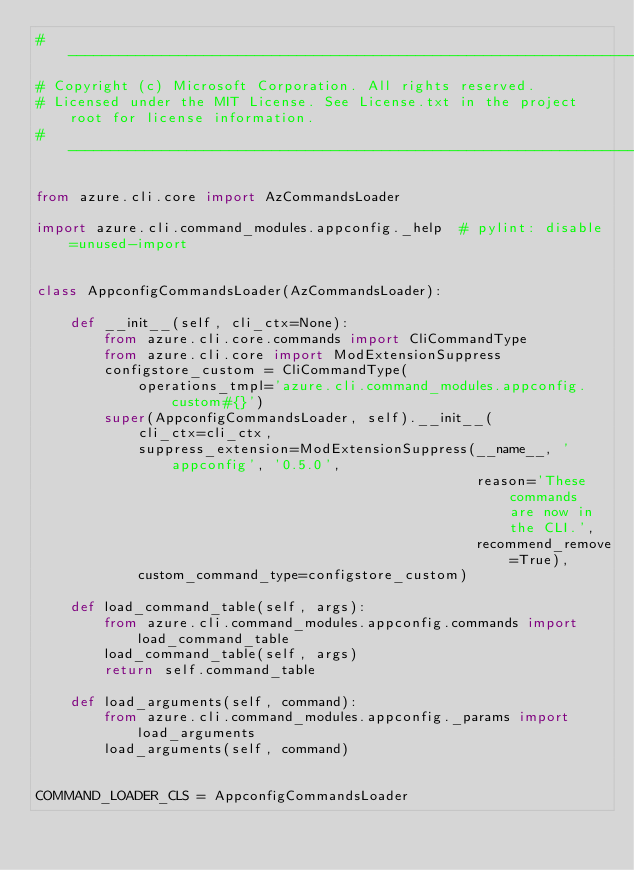<code> <loc_0><loc_0><loc_500><loc_500><_Python_># --------------------------------------------------------------------------------------------
# Copyright (c) Microsoft Corporation. All rights reserved.
# Licensed under the MIT License. See License.txt in the project root for license information.
# --------------------------------------------------------------------------------------------

from azure.cli.core import AzCommandsLoader

import azure.cli.command_modules.appconfig._help  # pylint: disable=unused-import


class AppconfigCommandsLoader(AzCommandsLoader):

    def __init__(self, cli_ctx=None):
        from azure.cli.core.commands import CliCommandType
        from azure.cli.core import ModExtensionSuppress
        configstore_custom = CliCommandType(
            operations_tmpl='azure.cli.command_modules.appconfig.custom#{}')
        super(AppconfigCommandsLoader, self).__init__(
            cli_ctx=cli_ctx,
            suppress_extension=ModExtensionSuppress(__name__, 'appconfig', '0.5.0',
                                                    reason='These commands are now in the CLI.',
                                                    recommend_remove=True),
            custom_command_type=configstore_custom)

    def load_command_table(self, args):
        from azure.cli.command_modules.appconfig.commands import load_command_table
        load_command_table(self, args)
        return self.command_table

    def load_arguments(self, command):
        from azure.cli.command_modules.appconfig._params import load_arguments
        load_arguments(self, command)


COMMAND_LOADER_CLS = AppconfigCommandsLoader
</code> 